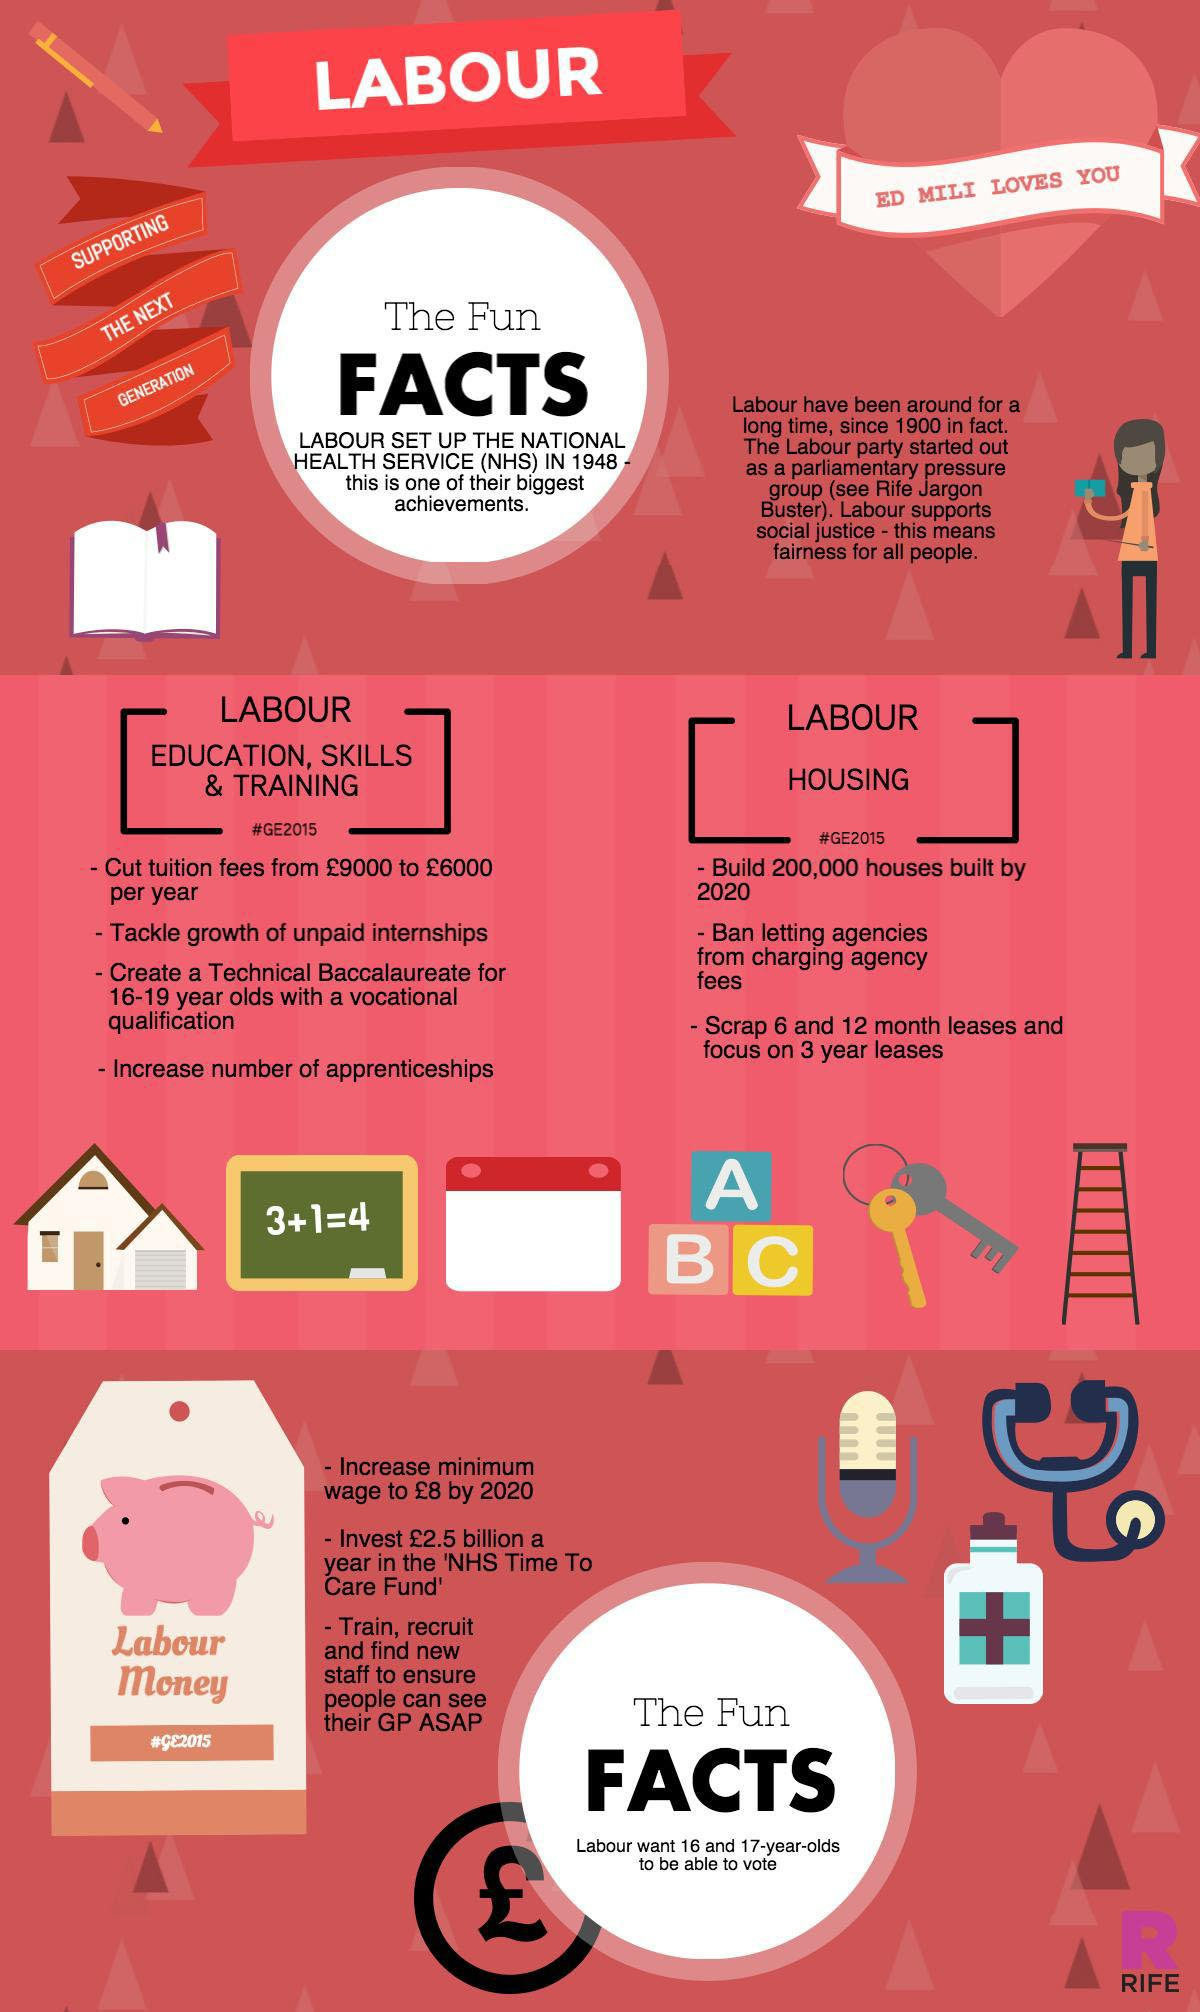Highlight a few significant elements in this photo. There are three points listed under the heading "Labour Housing. The word written in the biggest font in the infographic is "FACTS. 